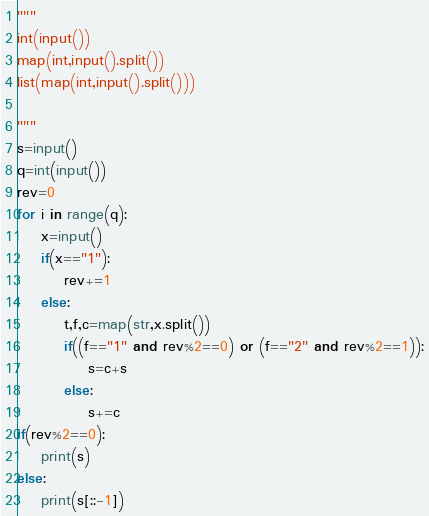Convert code to text. <code><loc_0><loc_0><loc_500><loc_500><_Python_>"""
int(input())
map(int,input().split())
list(map(int,input().split()))

"""
s=input()
q=int(input())
rev=0
for i in range(q):
    x=input()
    if(x=="1"):
        rev+=1
    else:
        t,f,c=map(str,x.split())
        if((f=="1" and rev%2==0) or (f=="2" and rev%2==1)):
            s=c+s
        else:
            s+=c
if(rev%2==0):
    print(s)
else:
    print(s[::-1])</code> 